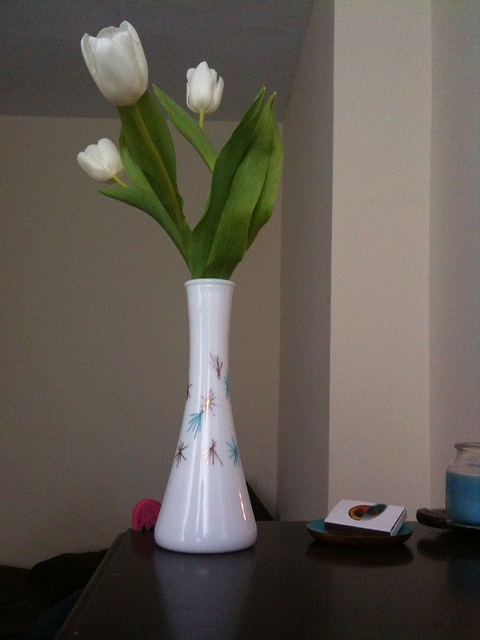Describe the objects in this image and their specific colors. I can see a vase in black, darkgray, lavender, and gray tones in this image. 